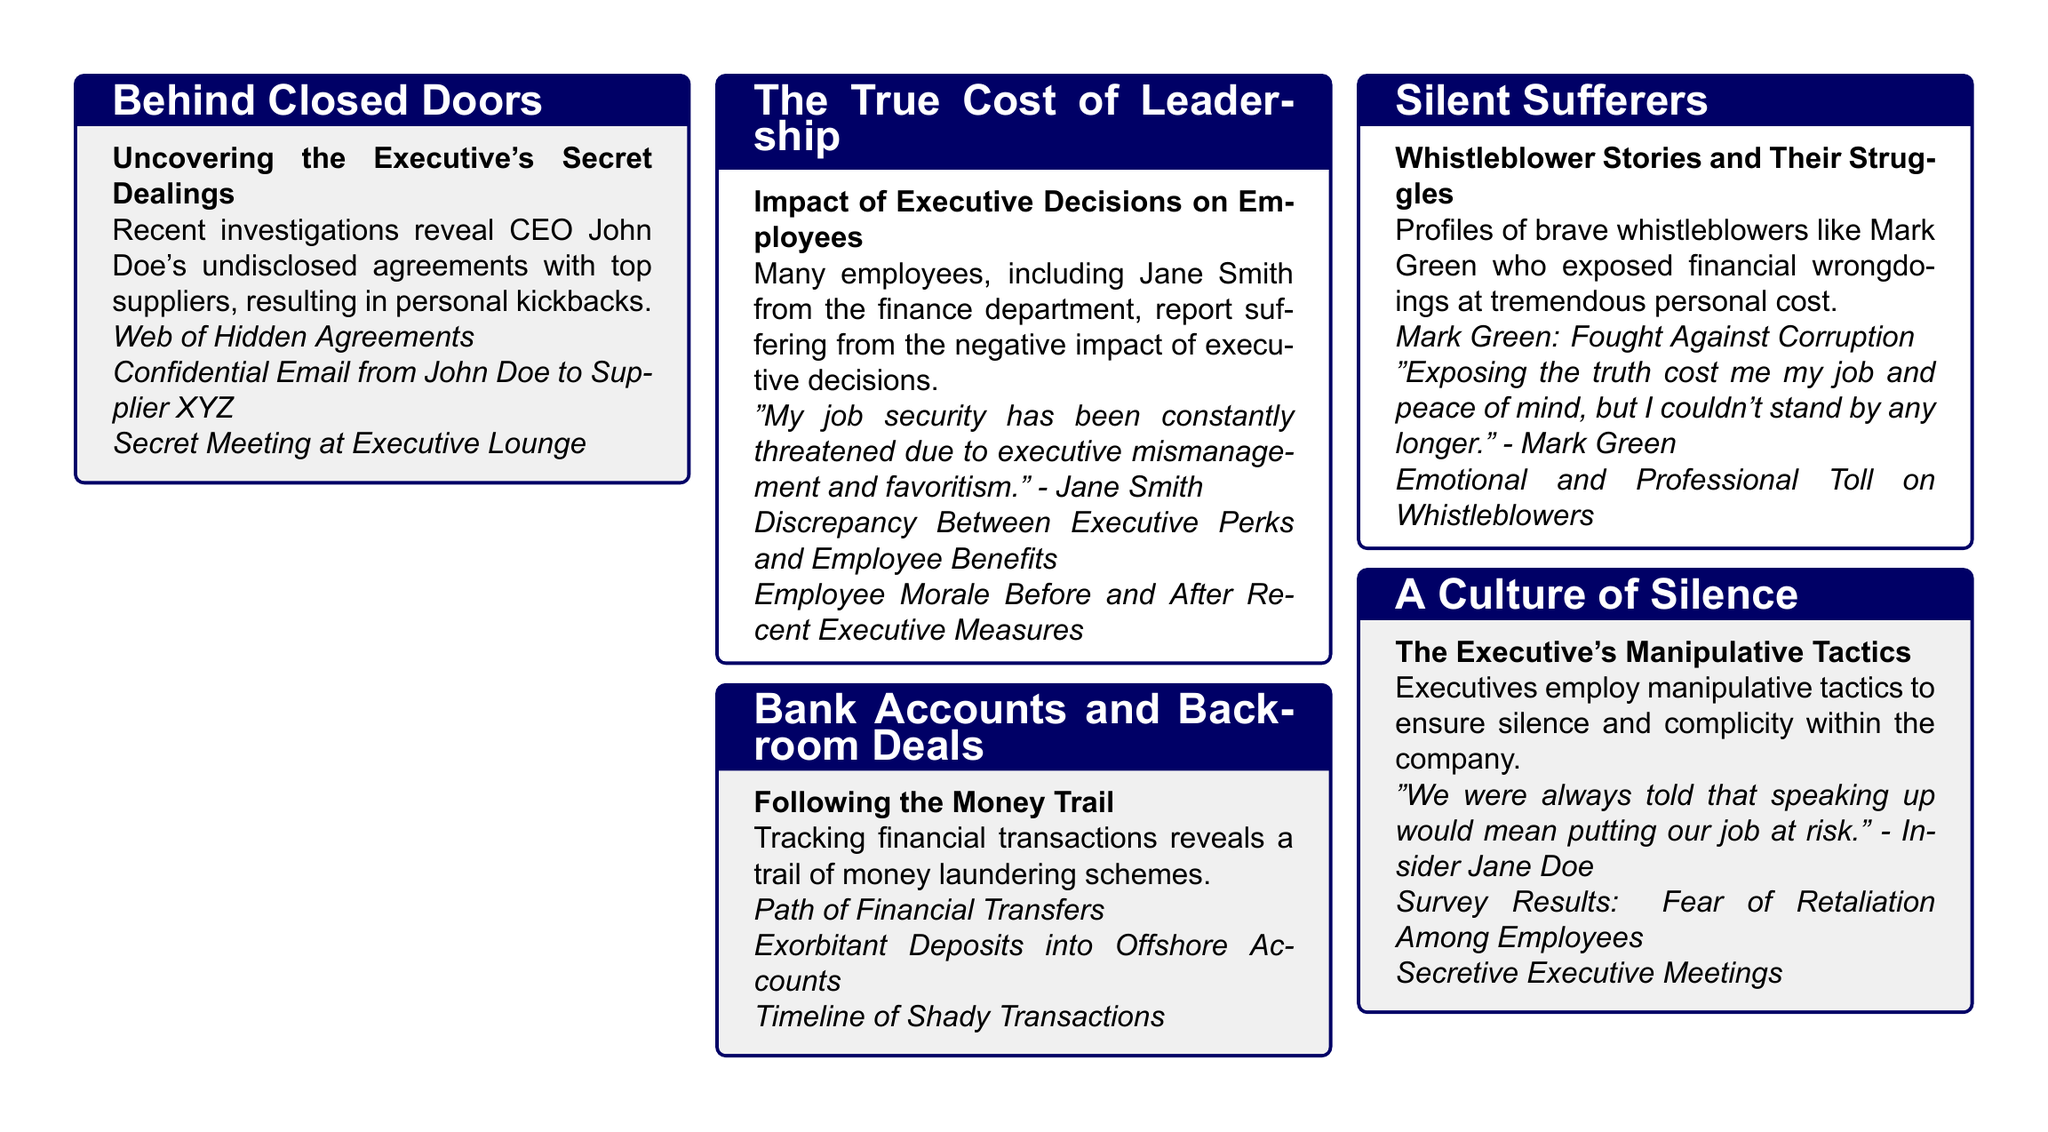what is the name of the CEO involved in secret dealings? The document specifically mentions the CEO's name as John Doe, who is involved in undisclosed agreements.
Answer: John Doe who reported suffering due to executive decisions? The document highlights Jane Smith from the finance department as someone who reported suffering from the negative impact of executive decisions.
Answer: Jane Smith what significant risk did employees face for speaking up? The insider testimony indicates that employees felt speaking up would risk their job security, pointing to fear among staff.
Answer: Job risk who is one of the profiles of whistleblowers discussed? Mark Green is highlighted as one of the brave whistleblowers who exposed financial wrongdoings, providing his personal story in the document.
Answer: Mark Green what is the document’s primary focus regarding financial transactions? The document centers around uncovering money laundering schemes tracked through financial transactions and backroom deals.
Answer: Money laundering schemes which tactic is discussed as a means for executives to ensure silence? The document discusses the manipulative tactics employed by executives to create a culture of fear and silence within the company.
Answer: Manipulative tactics what is the general sentiment of employees towards the recent executive measures? The document indicates a negative response, particularly regarding employee morale before and after the measures were implemented.
Answer: Negative response what type of visual aids are used in this investigative report? The document utilizes infographics such as pie charts, bar graphs, and flowcharts to illustrate various points throughout the investigation.
Answer: Infographics what emotional impact is mentioned regarding whistleblowers? The document notes the emotional and professional toll faced by whistleblowers who have exposed misconduct, emphasizing their personal struggles.
Answer: Emotional toll 